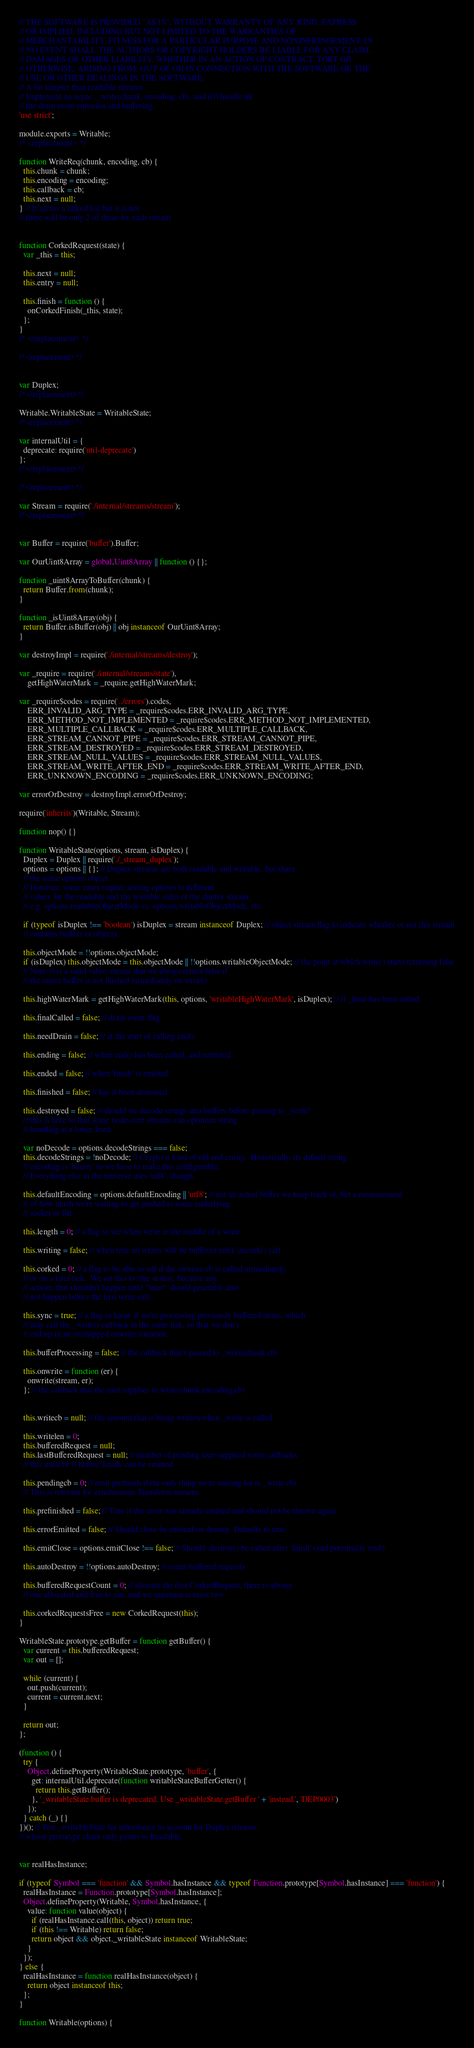Convert code to text. <code><loc_0><loc_0><loc_500><loc_500><_JavaScript_>// THE SOFTWARE IS PROVIDED "AS IS", WITHOUT WARRANTY OF ANY KIND, EXPRESS
// OR IMPLIED, INCLUDING BUT NOT LIMITED TO THE WARRANTIES OF
// MERCHANTABILITY, FITNESS FOR A PARTICULAR PURPOSE AND NONINFRINGEMENT. IN
// NO EVENT SHALL THE AUTHORS OR COPYRIGHT HOLDERS BE LIABLE FOR ANY CLAIM,
// DAMAGES OR OTHER LIABILITY, WHETHER IN AN ACTION OF CONTRACT, TORT OR
// OTHERWISE, ARISING FROM, OUT OF OR IN CONNECTION WITH THE SOFTWARE OR THE
// USE OR OTHER DEALINGS IN THE SOFTWARE.
// A bit simpler than readable streams.
// Implement an async ._write(chunk, encoding, cb), and it'll handle all
// the drain event emission and buffering.
'use strict';

module.exports = Writable;
/* <replacement> */

function WriteReq(chunk, encoding, cb) {
  this.chunk = chunk;
  this.encoding = encoding;
  this.callback = cb;
  this.next = null;
} // It seems a linked list but it is not
// there will be only 2 of these for each stream


function CorkedRequest(state) {
  var _this = this;

  this.next = null;
  this.entry = null;

  this.finish = function () {
    onCorkedFinish(_this, state);
  };
}
/* </replacement> */

/*<replacement>*/


var Duplex;
/*</replacement>*/

Writable.WritableState = WritableState;
/*<replacement>*/

var internalUtil = {
  deprecate: require('util-deprecate')
};
/*</replacement>*/

/*<replacement>*/

var Stream = require('./internal/streams/stream');
/*</replacement>*/


var Buffer = require('buffer').Buffer;

var OurUint8Array = global.Uint8Array || function () {};

function _uint8ArrayToBuffer(chunk) {
  return Buffer.from(chunk);
}

function _isUint8Array(obj) {
  return Buffer.isBuffer(obj) || obj instanceof OurUint8Array;
}

var destroyImpl = require('./internal/streams/destroy');

var _require = require('./internal/streams/state'),
    getHighWaterMark = _require.getHighWaterMark;

var _require$codes = require('../errors').codes,
    ERR_INVALID_ARG_TYPE = _require$codes.ERR_INVALID_ARG_TYPE,
    ERR_METHOD_NOT_IMPLEMENTED = _require$codes.ERR_METHOD_NOT_IMPLEMENTED,
    ERR_MULTIPLE_CALLBACK = _require$codes.ERR_MULTIPLE_CALLBACK,
    ERR_STREAM_CANNOT_PIPE = _require$codes.ERR_STREAM_CANNOT_PIPE,
    ERR_STREAM_DESTROYED = _require$codes.ERR_STREAM_DESTROYED,
    ERR_STREAM_NULL_VALUES = _require$codes.ERR_STREAM_NULL_VALUES,
    ERR_STREAM_WRITE_AFTER_END = _require$codes.ERR_STREAM_WRITE_AFTER_END,
    ERR_UNKNOWN_ENCODING = _require$codes.ERR_UNKNOWN_ENCODING;

var errorOrDestroy = destroyImpl.errorOrDestroy;

require('inherits')(Writable, Stream);

function nop() {}

function WritableState(options, stream, isDuplex) {
  Duplex = Duplex || require('./_stream_duplex');
  options = options || {}; // Duplex streams are both readable and writable, but share
  // the same options object.
  // However, some cases require setting options to different
  // values for the readable and the writable sides of the duplex stream,
  // e.g. options.readableObjectMode vs. options.writableObjectMode, etc.

  if (typeof isDuplex !== 'boolean') isDuplex = stream instanceof Duplex; // object stream flag to indicate whether or not this stream
  // contains buffers or objects.

  this.objectMode = !!options.objectMode;
  if (isDuplex) this.objectMode = this.objectMode || !!options.writableObjectMode; // the point at which write() starts returning false
  // Note: 0 is a valid value, means that we always return false if
  // the entire buffer is not flushed immediately on write()

  this.highWaterMark = getHighWaterMark(this, options, 'writableHighWaterMark', isDuplex); // if _final has been called

  this.finalCalled = false; // drain event flag.

  this.needDrain = false; // at the start of calling end()

  this.ending = false; // when end() has been called, and returned

  this.ended = false; // when 'finish' is emitted

  this.finished = false; // has it been destroyed

  this.destroyed = false; // should we decode strings into buffers before passing to _write?
  // this is here so that some node-core streams can optimize string
  // handling at a lower level.

  var noDecode = options.decodeStrings === false;
  this.decodeStrings = !noDecode; // Crypto is kind of old and crusty.  Historically, its default string
  // encoding is 'binary' so we have to make this configurable.
  // Everything else in the universe uses 'utf8', though.

  this.defaultEncoding = options.defaultEncoding || 'utf8'; // not an actual buffer we keep track of, but a measurement
  // of how much we're waiting to get pushed to some underlying
  // socket or file.

  this.length = 0; // a flag to see when we're in the middle of a write.

  this.writing = false; // when true all writes will be buffered until .uncork() call

  this.corked = 0; // a flag to be able to tell if the onwrite cb is called immediately,
  // or on a later tick.  We set this to true at first, because any
  // actions that shouldn't happen until "later" should generally also
  // not happen before the first write call.

  this.sync = true; // a flag to know if we're processing previously buffered items, which
  // may call the _write() callback in the same tick, so that we don't
  // end up in an overlapped onwrite situation.

  this.bufferProcessing = false; // the callback that's passed to _write(chunk,cb)

  this.onwrite = function (er) {
    onwrite(stream, er);
  }; // the callback that the user supplies to write(chunk,encoding,cb)


  this.writecb = null; // the amount that is being written when _write is called.

  this.writelen = 0;
  this.bufferedRequest = null;
  this.lastBufferedRequest = null; // number of pending user-supplied write callbacks
  // this must be 0 before 'finish' can be emitted

  this.pendingcb = 0; // emit prefinish if the only thing we're waiting for is _write cbs
  // This is relevant for synchronous Transform streams

  this.prefinished = false; // True if the error was already emitted and should not be thrown again

  this.errorEmitted = false; // Should close be emitted on destroy. Defaults to true.

  this.emitClose = options.emitClose !== false; // Should .destroy() be called after 'finish' (and potentially 'end')

  this.autoDestroy = !!options.autoDestroy; // count buffered requests

  this.bufferedRequestCount = 0; // allocate the first CorkedRequest, there is always
  // one allocated and free to use, and we maintain at most two

  this.corkedRequestsFree = new CorkedRequest(this);
}

WritableState.prototype.getBuffer = function getBuffer() {
  var current = this.bufferedRequest;
  var out = [];

  while (current) {
    out.push(current);
    current = current.next;
  }

  return out;
};

(function () {
  try {
    Object.defineProperty(WritableState.prototype, 'buffer', {
      get: internalUtil.deprecate(function writableStateBufferGetter() {
        return this.getBuffer();
      }, '_writableState.buffer is deprecated. Use _writableState.getBuffer ' + 'instead.', 'DEP0003')
    });
  } catch (_) {}
})(); // Test _writableState for inheritance to account for Duplex streams,
// whose prototype chain only points to Readable.


var realHasInstance;

if (typeof Symbol === 'function' && Symbol.hasInstance && typeof Function.prototype[Symbol.hasInstance] === 'function') {
  realHasInstance = Function.prototype[Symbol.hasInstance];
  Object.defineProperty(Writable, Symbol.hasInstance, {
    value: function value(object) {
      if (realHasInstance.call(this, object)) return true;
      if (this !== Writable) return false;
      return object && object._writableState instanceof WritableState;
    }
  });
} else {
  realHasInstance = function realHasInstance(object) {
    return object instanceof this;
  };
}

function Writable(options) {</code> 